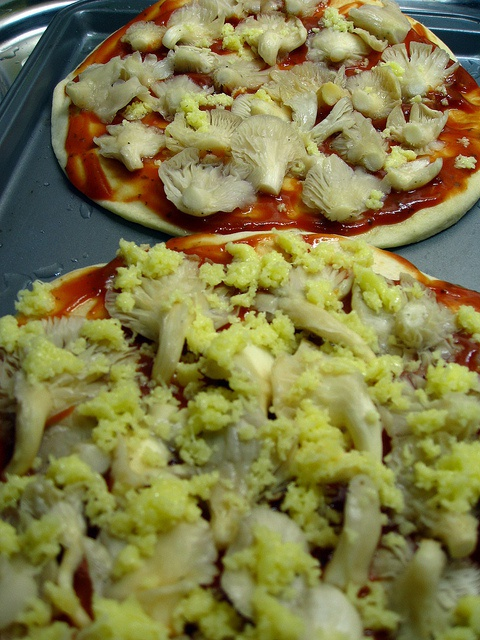Describe the objects in this image and their specific colors. I can see broccoli in teal and olive tones, pizza in teal, tan, maroon, and khaki tones, broccoli in teal and olive tones, broccoli in teal, tan, and beige tones, and broccoli in teal, tan, khaki, and olive tones in this image. 